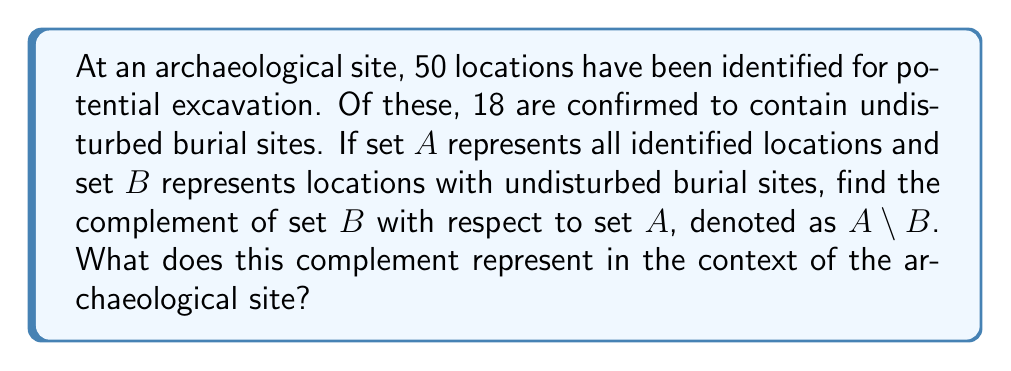What is the answer to this math problem? To solve this problem, we need to understand the concept of set complement and its application in this archaeological context.

1. Define the sets:
   $A$ = {all identified locations}
   $B$ = {locations with undisturbed burial sites}

2. The complement of $B$ with respect to $A$, denoted as $A \setminus B$, represents all elements in $A$ that are not in $B$.

3. To find the number of elements in $A \setminus B$:
   $|A \setminus B| = |A| - |B|$
   Where $|A|$ is the total number of identified locations and $|B|$ is the number of locations with undisturbed burial sites.

4. Given information:
   $|A| = 50$ (total identified locations)
   $|B| = 18$ (locations with undisturbed burial sites)

5. Calculate:
   $|A \setminus B| = 50 - 18 = 32$

6. Interpretation:
   The complement $A \setminus B$ represents the locations that have been identified for potential excavation but do not contain undisturbed burial sites. These are areas where archaeological work can proceed without the immediate concern of disturbing human remains.
Answer: $A \setminus B = 32$ locations. These represent archaeological locations without confirmed undisturbed burial sites, where excavation may proceed with less concern for disturbing human remains. 